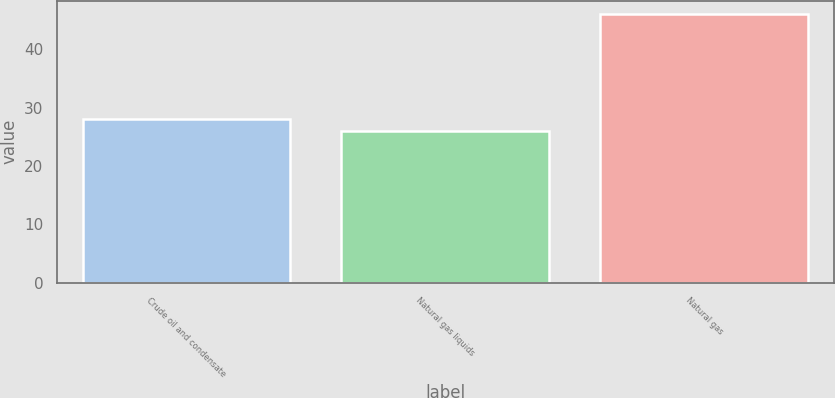Convert chart. <chart><loc_0><loc_0><loc_500><loc_500><bar_chart><fcel>Crude oil and condensate<fcel>Natural gas liquids<fcel>Natural gas<nl><fcel>28<fcel>26<fcel>46<nl></chart> 